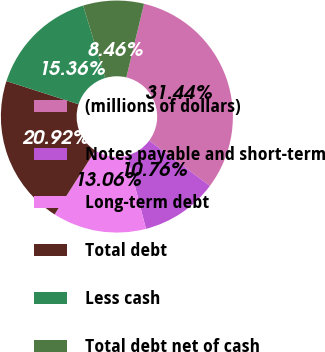<chart> <loc_0><loc_0><loc_500><loc_500><pie_chart><fcel>(millions of dollars)<fcel>Notes payable and short-term<fcel>Long-term debt<fcel>Total debt<fcel>Less cash<fcel>Total debt net of cash<nl><fcel>31.44%<fcel>10.76%<fcel>13.06%<fcel>20.92%<fcel>15.36%<fcel>8.46%<nl></chart> 